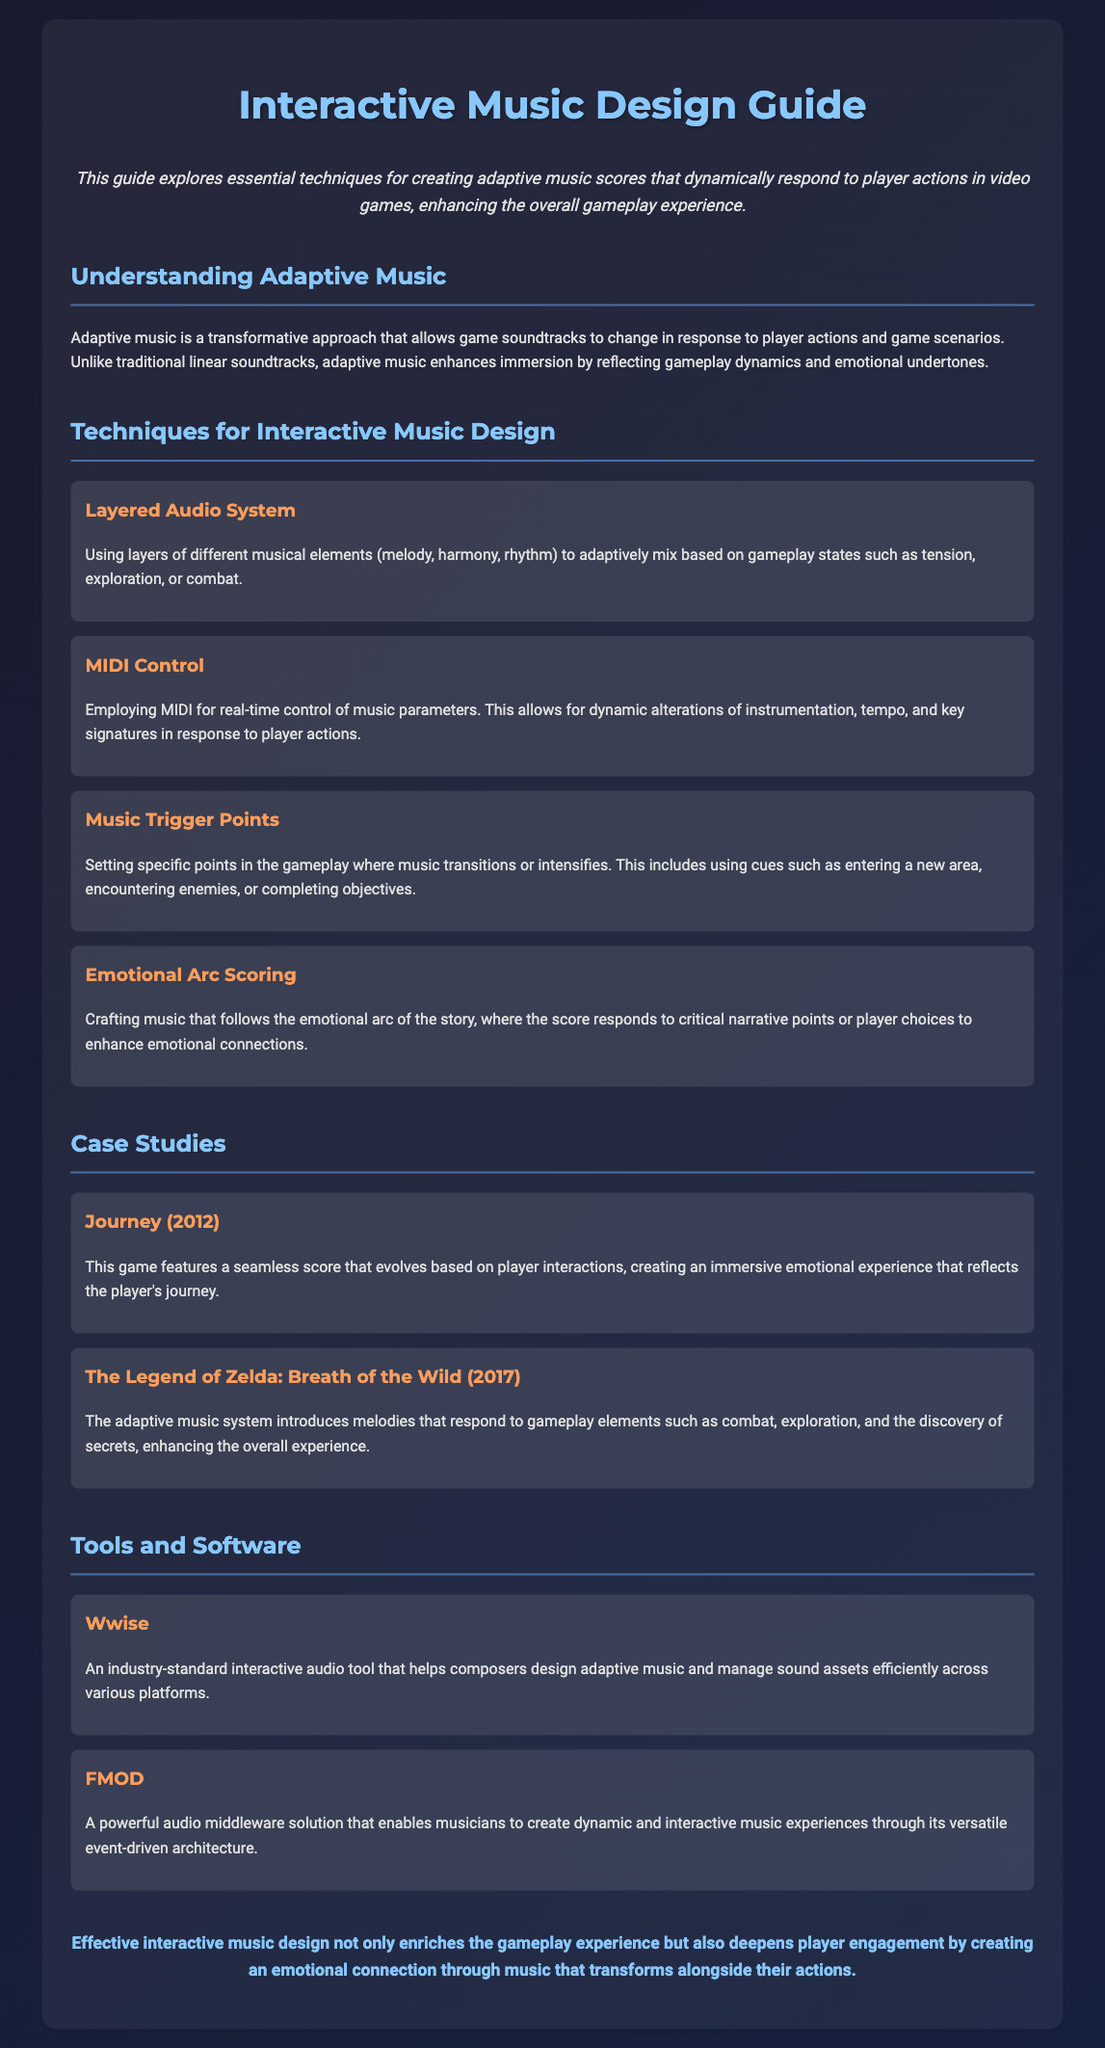What is the main purpose of the guide? The document introduces techniques for creating adaptive music scores that respond to player actions and enhance gameplay moments.
Answer: Enhancing gameplay moments What is the first technique mentioned in the document? The first technique listed under "Techniques for Interactive Music Design" is "Layered Audio System."
Answer: Layered Audio System Which game is cited as a case study from 2012? The document mentions "Journey" as a case study from the year 2012.
Answer: Journey What two tools are highlighted in the Tools and Software section? The document lists "Wwise" and "FMOD" as highlighted tools.
Answer: Wwise, FMOD How does adaptive music differ from traditional soundtracks? Adaptive music changes in response to player actions and game scenarios, enhancing immersion and reflecting gameplay dynamics.
Answer: Changes in response to player actions What is the emotional impact of the "Emotional Arc Scoring" technique? This technique enhances emotional connections by crafting music that responds to critical narrative points or player choices.
Answer: Enhances emotional connections What studio developed "The Legend of Zelda: Breath of the Wild"? The document does not specify the studio's name in this section, focusing instead on the game's adaptive music system.
Answer: Not specified How many techniques for Interactive Music Design are listed in the document? There are four techniques listed under the Techniques for Interactive Music Design section.
Answer: Four 